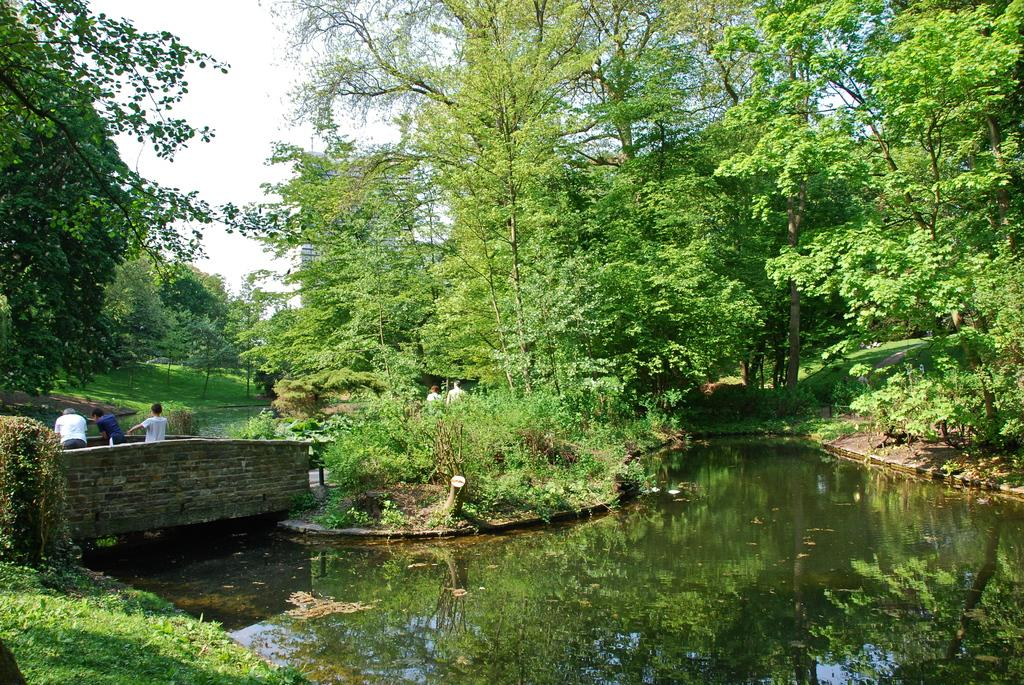What is the main feature of the image? The main feature of the image is water. What structure can be seen crossing the water? There is a bridge in the image. How many people are on the bridge? There are three persons on the bridge. What type of natural environment is visible in the image? There are many trees in the image. What is visible in the background of the image? The sky is visible in the background of the image. What type of feather can be seen on the throne in the image? There is no throne or feather present in the image. How many rats are visible on the bridge in the image? There are no rats visible on the bridge or in the image. 